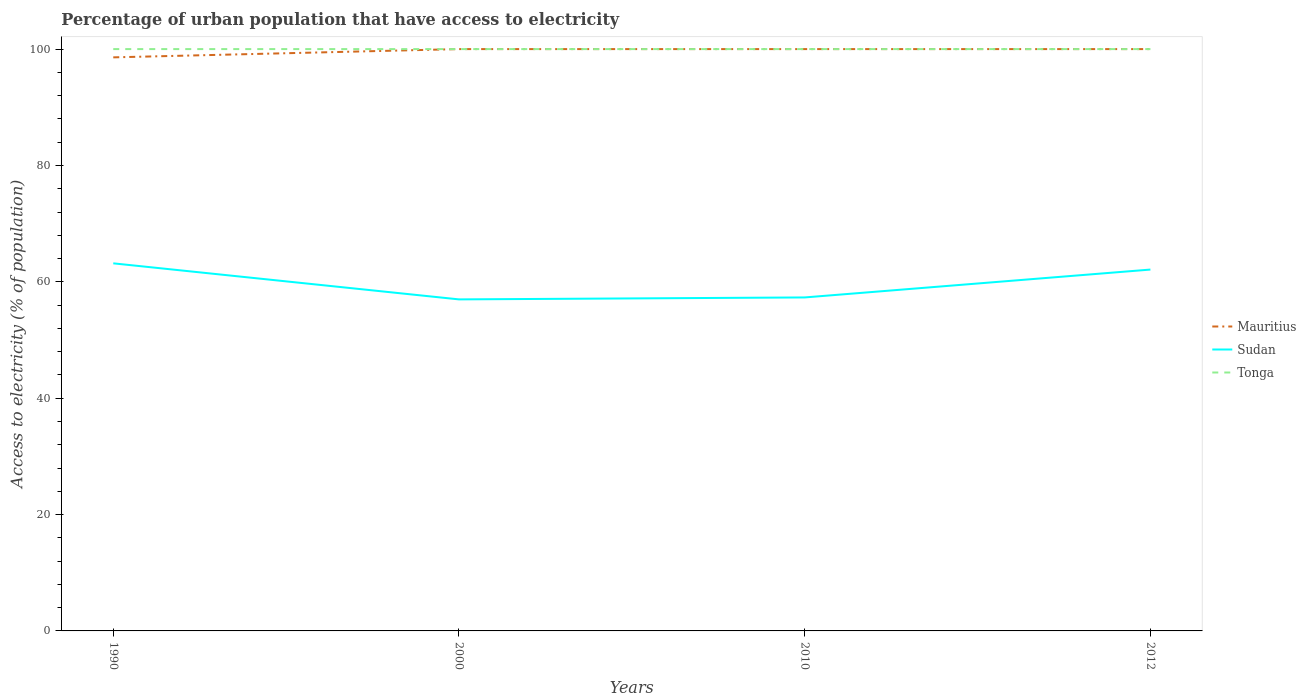How many different coloured lines are there?
Your answer should be very brief. 3. Across all years, what is the maximum percentage of urban population that have access to electricity in Sudan?
Give a very brief answer. 56.98. What is the total percentage of urban population that have access to electricity in Sudan in the graph?
Offer a very short reply. 1.07. What is the difference between the highest and the second highest percentage of urban population that have access to electricity in Sudan?
Your response must be concise. 6.2. Is the percentage of urban population that have access to electricity in Mauritius strictly greater than the percentage of urban population that have access to electricity in Tonga over the years?
Give a very brief answer. No. How many years are there in the graph?
Offer a terse response. 4. Are the values on the major ticks of Y-axis written in scientific E-notation?
Provide a succinct answer. No. What is the title of the graph?
Offer a very short reply. Percentage of urban population that have access to electricity. Does "Estonia" appear as one of the legend labels in the graph?
Provide a short and direct response. No. What is the label or title of the Y-axis?
Provide a succinct answer. Access to electricity (% of population). What is the Access to electricity (% of population) in Mauritius in 1990?
Offer a very short reply. 98.58. What is the Access to electricity (% of population) of Sudan in 1990?
Make the answer very short. 63.18. What is the Access to electricity (% of population) of Tonga in 1990?
Your answer should be very brief. 100. What is the Access to electricity (% of population) of Sudan in 2000?
Your answer should be very brief. 56.98. What is the Access to electricity (% of population) of Mauritius in 2010?
Provide a short and direct response. 100. What is the Access to electricity (% of population) in Sudan in 2010?
Your answer should be compact. 57.32. What is the Access to electricity (% of population) of Sudan in 2012?
Your answer should be very brief. 62.11. Across all years, what is the maximum Access to electricity (% of population) of Mauritius?
Keep it short and to the point. 100. Across all years, what is the maximum Access to electricity (% of population) of Sudan?
Your answer should be compact. 63.18. Across all years, what is the minimum Access to electricity (% of population) in Mauritius?
Offer a very short reply. 98.58. Across all years, what is the minimum Access to electricity (% of population) of Sudan?
Provide a succinct answer. 56.98. Across all years, what is the minimum Access to electricity (% of population) in Tonga?
Your response must be concise. 100. What is the total Access to electricity (% of population) of Mauritius in the graph?
Your answer should be compact. 398.58. What is the total Access to electricity (% of population) of Sudan in the graph?
Your response must be concise. 239.58. What is the total Access to electricity (% of population) of Tonga in the graph?
Ensure brevity in your answer.  400. What is the difference between the Access to electricity (% of population) in Mauritius in 1990 and that in 2000?
Ensure brevity in your answer.  -1.42. What is the difference between the Access to electricity (% of population) of Sudan in 1990 and that in 2000?
Provide a short and direct response. 6.2. What is the difference between the Access to electricity (% of population) of Mauritius in 1990 and that in 2010?
Offer a very short reply. -1.42. What is the difference between the Access to electricity (% of population) of Sudan in 1990 and that in 2010?
Your answer should be compact. 5.86. What is the difference between the Access to electricity (% of population) in Mauritius in 1990 and that in 2012?
Offer a very short reply. -1.42. What is the difference between the Access to electricity (% of population) of Sudan in 1990 and that in 2012?
Make the answer very short. 1.07. What is the difference between the Access to electricity (% of population) of Tonga in 1990 and that in 2012?
Provide a succinct answer. 0. What is the difference between the Access to electricity (% of population) of Sudan in 2000 and that in 2010?
Offer a very short reply. -0.34. What is the difference between the Access to electricity (% of population) of Mauritius in 2000 and that in 2012?
Your response must be concise. 0. What is the difference between the Access to electricity (% of population) in Sudan in 2000 and that in 2012?
Offer a terse response. -5.13. What is the difference between the Access to electricity (% of population) of Sudan in 2010 and that in 2012?
Give a very brief answer. -4.79. What is the difference between the Access to electricity (% of population) in Tonga in 2010 and that in 2012?
Offer a very short reply. 0. What is the difference between the Access to electricity (% of population) of Mauritius in 1990 and the Access to electricity (% of population) of Sudan in 2000?
Offer a terse response. 41.6. What is the difference between the Access to electricity (% of population) of Mauritius in 1990 and the Access to electricity (% of population) of Tonga in 2000?
Your answer should be compact. -1.42. What is the difference between the Access to electricity (% of population) of Sudan in 1990 and the Access to electricity (% of population) of Tonga in 2000?
Make the answer very short. -36.82. What is the difference between the Access to electricity (% of population) in Mauritius in 1990 and the Access to electricity (% of population) in Sudan in 2010?
Provide a succinct answer. 41.26. What is the difference between the Access to electricity (% of population) of Mauritius in 1990 and the Access to electricity (% of population) of Tonga in 2010?
Keep it short and to the point. -1.42. What is the difference between the Access to electricity (% of population) in Sudan in 1990 and the Access to electricity (% of population) in Tonga in 2010?
Your answer should be compact. -36.82. What is the difference between the Access to electricity (% of population) of Mauritius in 1990 and the Access to electricity (% of population) of Sudan in 2012?
Offer a terse response. 36.47. What is the difference between the Access to electricity (% of population) of Mauritius in 1990 and the Access to electricity (% of population) of Tonga in 2012?
Make the answer very short. -1.42. What is the difference between the Access to electricity (% of population) of Sudan in 1990 and the Access to electricity (% of population) of Tonga in 2012?
Ensure brevity in your answer.  -36.82. What is the difference between the Access to electricity (% of population) of Mauritius in 2000 and the Access to electricity (% of population) of Sudan in 2010?
Make the answer very short. 42.68. What is the difference between the Access to electricity (% of population) of Mauritius in 2000 and the Access to electricity (% of population) of Tonga in 2010?
Provide a succinct answer. 0. What is the difference between the Access to electricity (% of population) of Sudan in 2000 and the Access to electricity (% of population) of Tonga in 2010?
Make the answer very short. -43.02. What is the difference between the Access to electricity (% of population) of Mauritius in 2000 and the Access to electricity (% of population) of Sudan in 2012?
Your response must be concise. 37.89. What is the difference between the Access to electricity (% of population) of Mauritius in 2000 and the Access to electricity (% of population) of Tonga in 2012?
Offer a very short reply. 0. What is the difference between the Access to electricity (% of population) of Sudan in 2000 and the Access to electricity (% of population) of Tonga in 2012?
Offer a very short reply. -43.02. What is the difference between the Access to electricity (% of population) of Mauritius in 2010 and the Access to electricity (% of population) of Sudan in 2012?
Keep it short and to the point. 37.89. What is the difference between the Access to electricity (% of population) of Sudan in 2010 and the Access to electricity (% of population) of Tonga in 2012?
Make the answer very short. -42.68. What is the average Access to electricity (% of population) of Mauritius per year?
Your answer should be very brief. 99.64. What is the average Access to electricity (% of population) in Sudan per year?
Offer a very short reply. 59.9. What is the average Access to electricity (% of population) in Tonga per year?
Your answer should be compact. 100. In the year 1990, what is the difference between the Access to electricity (% of population) of Mauritius and Access to electricity (% of population) of Sudan?
Give a very brief answer. 35.4. In the year 1990, what is the difference between the Access to electricity (% of population) in Mauritius and Access to electricity (% of population) in Tonga?
Provide a short and direct response. -1.42. In the year 1990, what is the difference between the Access to electricity (% of population) of Sudan and Access to electricity (% of population) of Tonga?
Offer a very short reply. -36.82. In the year 2000, what is the difference between the Access to electricity (% of population) of Mauritius and Access to electricity (% of population) of Sudan?
Make the answer very short. 43.02. In the year 2000, what is the difference between the Access to electricity (% of population) in Sudan and Access to electricity (% of population) in Tonga?
Your answer should be very brief. -43.02. In the year 2010, what is the difference between the Access to electricity (% of population) in Mauritius and Access to electricity (% of population) in Sudan?
Offer a terse response. 42.68. In the year 2010, what is the difference between the Access to electricity (% of population) in Mauritius and Access to electricity (% of population) in Tonga?
Your answer should be very brief. 0. In the year 2010, what is the difference between the Access to electricity (% of population) of Sudan and Access to electricity (% of population) of Tonga?
Your response must be concise. -42.68. In the year 2012, what is the difference between the Access to electricity (% of population) in Mauritius and Access to electricity (% of population) in Sudan?
Give a very brief answer. 37.89. In the year 2012, what is the difference between the Access to electricity (% of population) of Sudan and Access to electricity (% of population) of Tonga?
Keep it short and to the point. -37.89. What is the ratio of the Access to electricity (% of population) of Mauritius in 1990 to that in 2000?
Keep it short and to the point. 0.99. What is the ratio of the Access to electricity (% of population) in Sudan in 1990 to that in 2000?
Offer a very short reply. 1.11. What is the ratio of the Access to electricity (% of population) of Mauritius in 1990 to that in 2010?
Your answer should be very brief. 0.99. What is the ratio of the Access to electricity (% of population) of Sudan in 1990 to that in 2010?
Your answer should be very brief. 1.1. What is the ratio of the Access to electricity (% of population) of Mauritius in 1990 to that in 2012?
Your answer should be very brief. 0.99. What is the ratio of the Access to electricity (% of population) of Sudan in 1990 to that in 2012?
Your answer should be very brief. 1.02. What is the ratio of the Access to electricity (% of population) of Tonga in 1990 to that in 2012?
Offer a terse response. 1. What is the ratio of the Access to electricity (% of population) in Mauritius in 2000 to that in 2010?
Ensure brevity in your answer.  1. What is the ratio of the Access to electricity (% of population) of Tonga in 2000 to that in 2010?
Offer a very short reply. 1. What is the ratio of the Access to electricity (% of population) in Mauritius in 2000 to that in 2012?
Offer a terse response. 1. What is the ratio of the Access to electricity (% of population) of Sudan in 2000 to that in 2012?
Provide a succinct answer. 0.92. What is the ratio of the Access to electricity (% of population) in Tonga in 2000 to that in 2012?
Your answer should be compact. 1. What is the ratio of the Access to electricity (% of population) of Mauritius in 2010 to that in 2012?
Ensure brevity in your answer.  1. What is the ratio of the Access to electricity (% of population) in Sudan in 2010 to that in 2012?
Your answer should be compact. 0.92. What is the difference between the highest and the second highest Access to electricity (% of population) of Mauritius?
Offer a terse response. 0. What is the difference between the highest and the second highest Access to electricity (% of population) in Sudan?
Ensure brevity in your answer.  1.07. What is the difference between the highest and the second highest Access to electricity (% of population) in Tonga?
Your response must be concise. 0. What is the difference between the highest and the lowest Access to electricity (% of population) of Mauritius?
Your answer should be very brief. 1.42. What is the difference between the highest and the lowest Access to electricity (% of population) of Sudan?
Offer a very short reply. 6.2. What is the difference between the highest and the lowest Access to electricity (% of population) of Tonga?
Offer a very short reply. 0. 